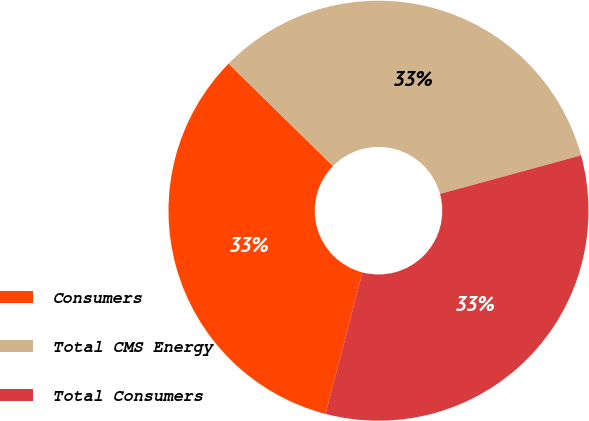<chart> <loc_0><loc_0><loc_500><loc_500><pie_chart><fcel>Consumers<fcel>Total CMS Energy<fcel>Total Consumers<nl><fcel>33.29%<fcel>33.4%<fcel>33.3%<nl></chart> 